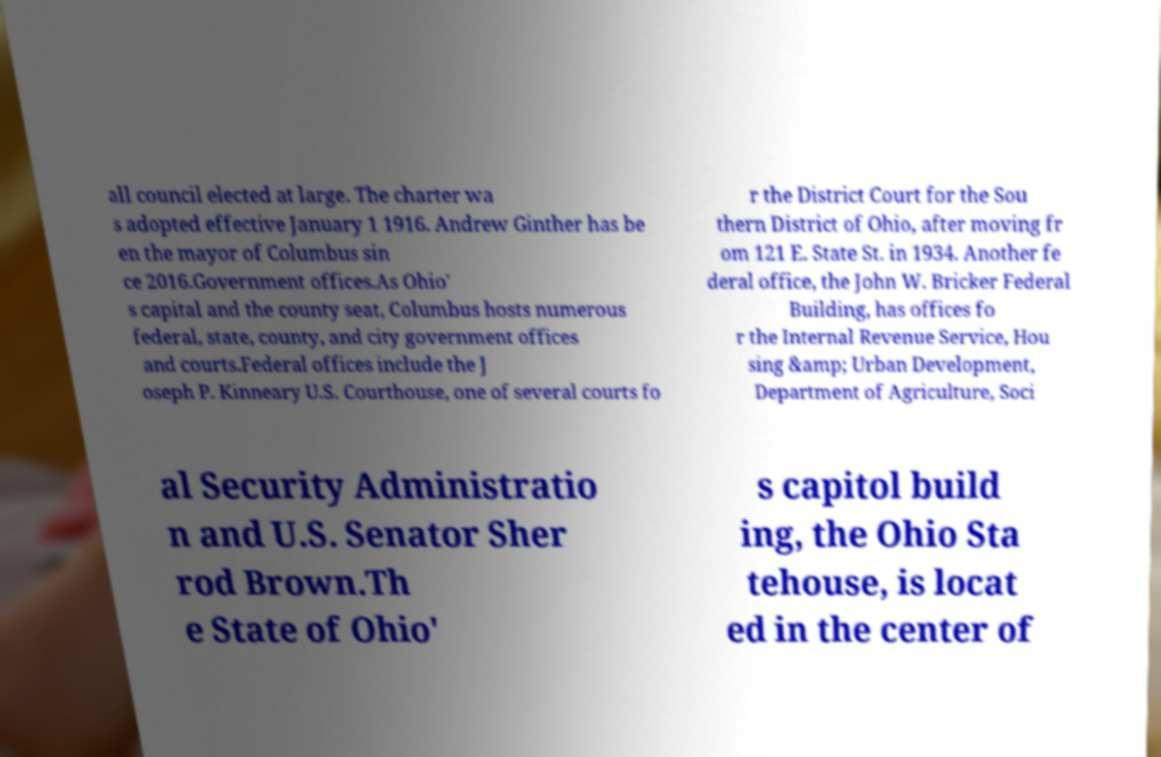Could you extract and type out the text from this image? all council elected at large. The charter wa s adopted effective January 1 1916. Andrew Ginther has be en the mayor of Columbus sin ce 2016.Government offices.As Ohio' s capital and the county seat, Columbus hosts numerous federal, state, county, and city government offices and courts.Federal offices include the J oseph P. Kinneary U.S. Courthouse, one of several courts fo r the District Court for the Sou thern District of Ohio, after moving fr om 121 E. State St. in 1934. Another fe deral office, the John W. Bricker Federal Building, has offices fo r the Internal Revenue Service, Hou sing &amp; Urban Development, Department of Agriculture, Soci al Security Administratio n and U.S. Senator Sher rod Brown.Th e State of Ohio' s capitol build ing, the Ohio Sta tehouse, is locat ed in the center of 